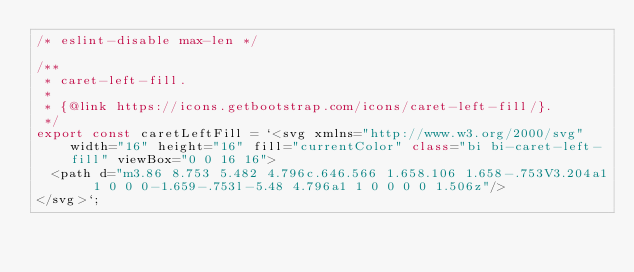<code> <loc_0><loc_0><loc_500><loc_500><_TypeScript_>/* eslint-disable max-len */

/**
 * caret-left-fill.
 *
 * {@link https://icons.getbootstrap.com/icons/caret-left-fill/}.
 */
export const caretLeftFill = `<svg xmlns="http://www.w3.org/2000/svg" width="16" height="16" fill="currentColor" class="bi bi-caret-left-fill" viewBox="0 0 16 16">
  <path d="m3.86 8.753 5.482 4.796c.646.566 1.658.106 1.658-.753V3.204a1 1 0 0 0-1.659-.753l-5.48 4.796a1 1 0 0 0 0 1.506z"/>
</svg>`;
</code> 